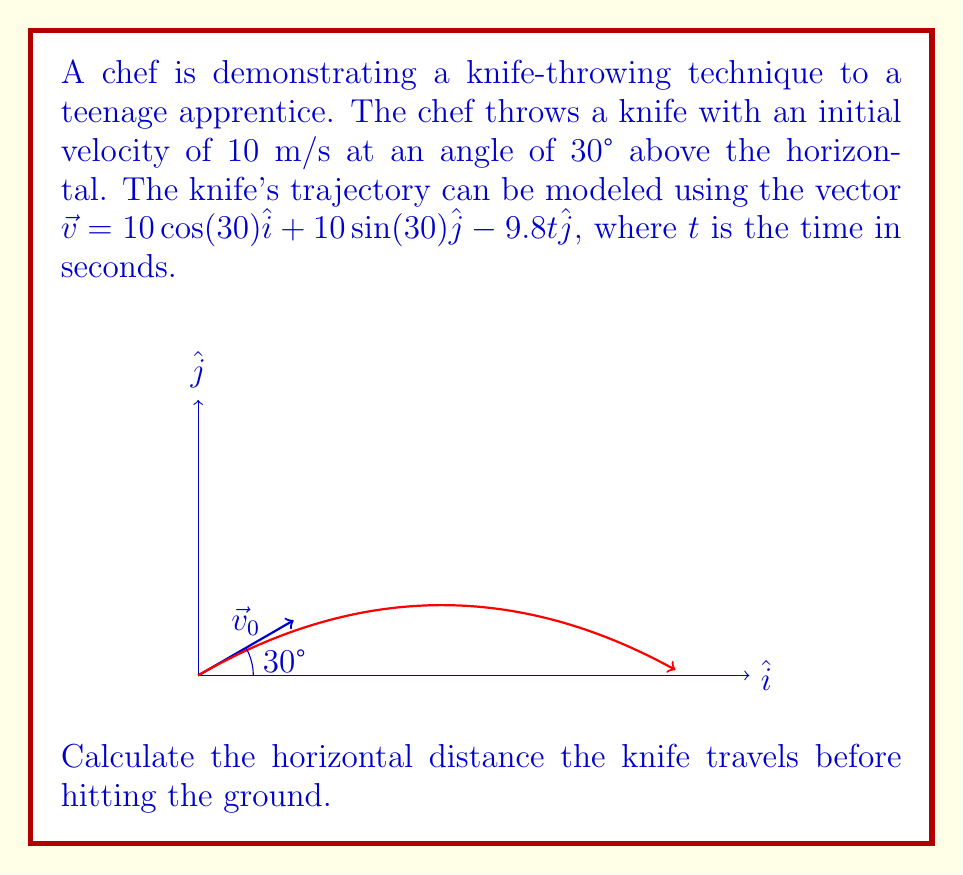Show me your answer to this math problem. Let's approach this step-by-step:

1) First, we need to find the time when the knife hits the ground. This occurs when the y-component of the position vector is zero.

2) The y-component of the position vector is given by:
   $y = 10\sin(30°)t - \frac{1}{2}(9.8)t^2$

3) Set this equal to zero and solve for t:
   $0 = 10\sin(30°)t - \frac{1}{2}(9.8)t^2$
   $0 = 5t - 4.9t^2$
   $4.9t^2 - 5t = 0$
   $t(4.9t - 5) = 0$

4) Solving this, we get $t = 0$ or $t = \frac{5}{4.9} \approx 1.02$ seconds. We use the non-zero solution.

5) Now that we know the time, we can find the horizontal distance by using the x-component of the velocity vector:
   $x = 10\cos(30°)t$

6) Substituting our t value:
   $x = 10\cos(30°)(1.02) \approx 8.84$ meters

Therefore, the knife travels approximately 8.84 meters horizontally before hitting the ground.
Answer: 8.84 meters 